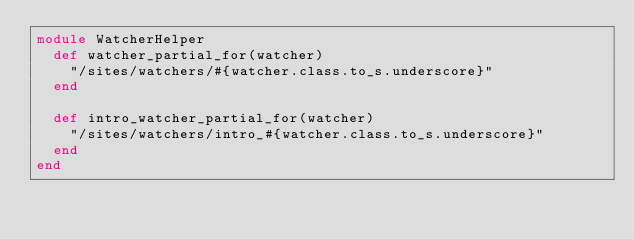Convert code to text. <code><loc_0><loc_0><loc_500><loc_500><_Ruby_>module WatcherHelper
  def watcher_partial_for(watcher)
    "/sites/watchers/#{watcher.class.to_s.underscore}"
  end

  def intro_watcher_partial_for(watcher)
    "/sites/watchers/intro_#{watcher.class.to_s.underscore}"
  end
end
</code> 